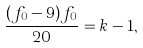<formula> <loc_0><loc_0><loc_500><loc_500>\frac { ( f _ { 0 } - 9 ) f _ { 0 } } { 2 0 } = k - 1 ,</formula> 